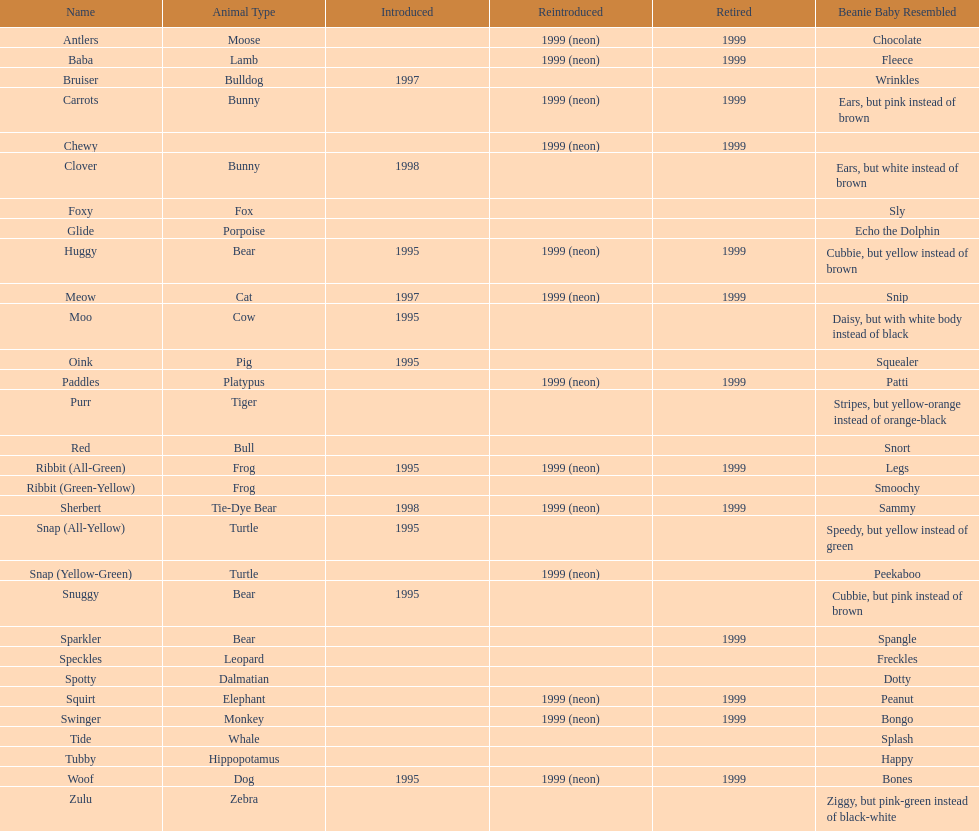Which is the only pillow pal without a listed animal type? Chewy. 